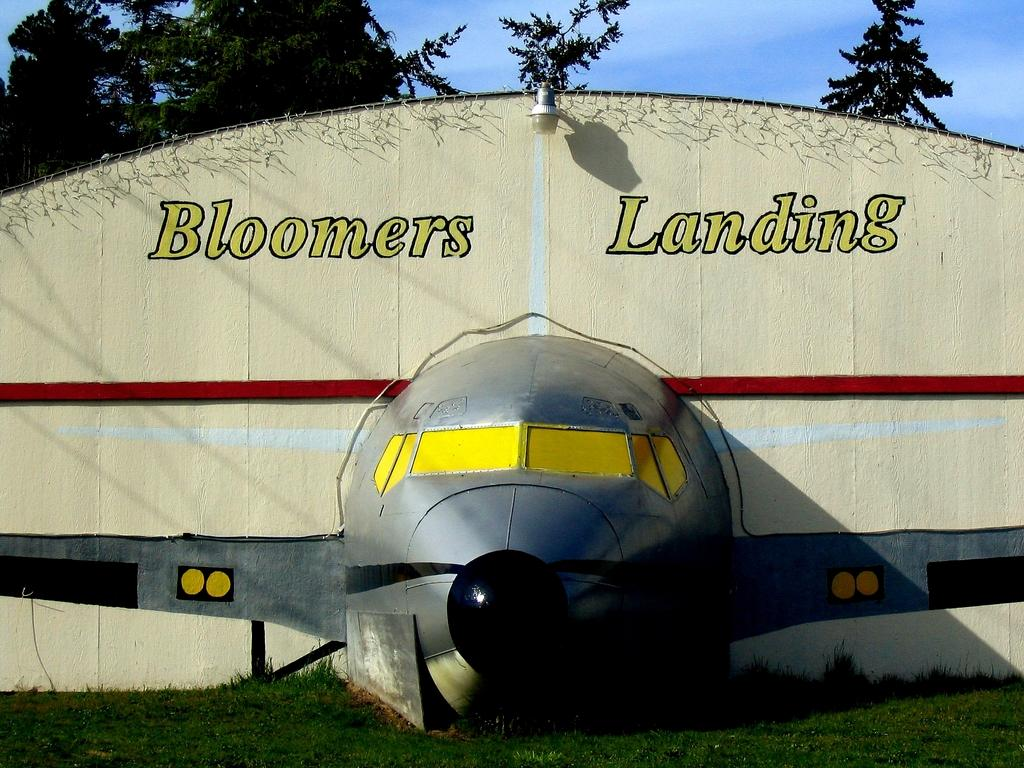Provide a one-sentence caption for the provided image. A model of an airplane decorates the walls of the Bloomers Landing hangar. 